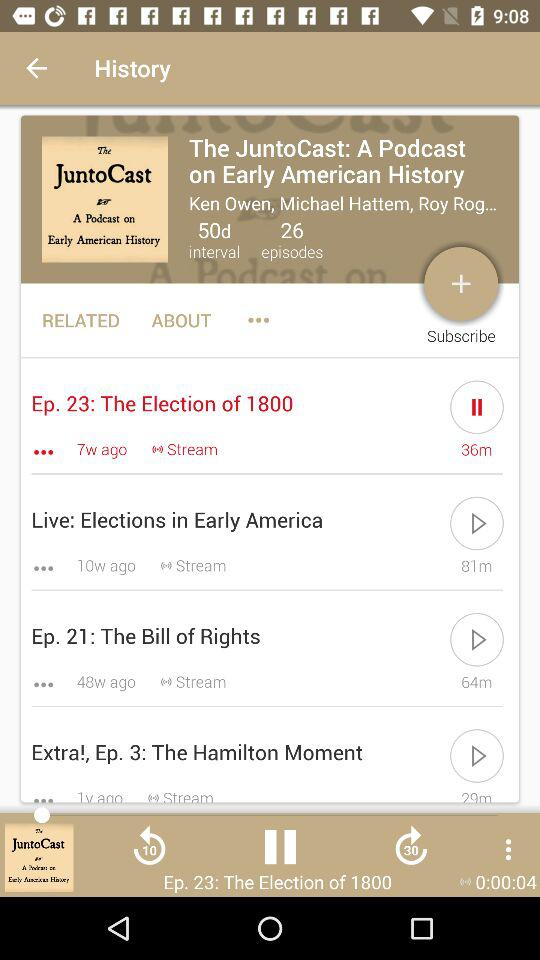What is the duration of the audio "The Bill of Rights"? The duration of the audio is 64m. 